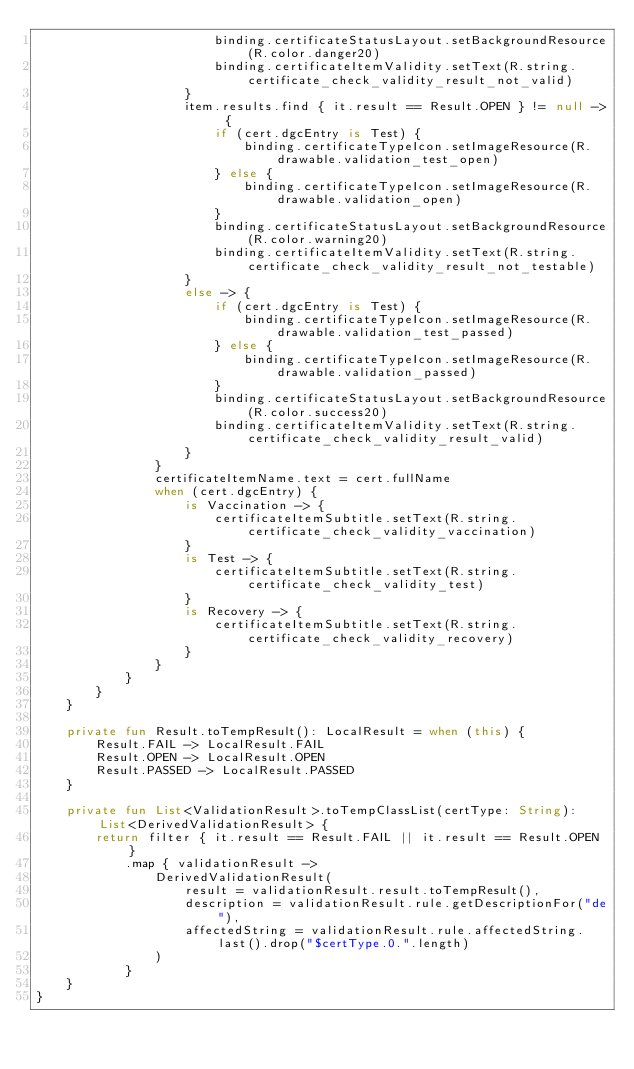<code> <loc_0><loc_0><loc_500><loc_500><_Kotlin_>                        binding.certificateStatusLayout.setBackgroundResource(R.color.danger20)
                        binding.certificateItemValidity.setText(R.string.certificate_check_validity_result_not_valid)
                    }
                    item.results.find { it.result == Result.OPEN } != null -> {
                        if (cert.dgcEntry is Test) {
                            binding.certificateTypeIcon.setImageResource(R.drawable.validation_test_open)
                        } else {
                            binding.certificateTypeIcon.setImageResource(R.drawable.validation_open)
                        }
                        binding.certificateStatusLayout.setBackgroundResource(R.color.warning20)
                        binding.certificateItemValidity.setText(R.string.certificate_check_validity_result_not_testable)
                    }
                    else -> {
                        if (cert.dgcEntry is Test) {
                            binding.certificateTypeIcon.setImageResource(R.drawable.validation_test_passed)
                        } else {
                            binding.certificateTypeIcon.setImageResource(R.drawable.validation_passed)
                        }
                        binding.certificateStatusLayout.setBackgroundResource(R.color.success20)
                        binding.certificateItemValidity.setText(R.string.certificate_check_validity_result_valid)
                    }
                }
                certificateItemName.text = cert.fullName
                when (cert.dgcEntry) {
                    is Vaccination -> {
                        certificateItemSubtitle.setText(R.string.certificate_check_validity_vaccination)
                    }
                    is Test -> {
                        certificateItemSubtitle.setText(R.string.certificate_check_validity_test)
                    }
                    is Recovery -> {
                        certificateItemSubtitle.setText(R.string.certificate_check_validity_recovery)
                    }
                }
            }
        }
    }

    private fun Result.toTempResult(): LocalResult = when (this) {
        Result.FAIL -> LocalResult.FAIL
        Result.OPEN -> LocalResult.OPEN
        Result.PASSED -> LocalResult.PASSED
    }

    private fun List<ValidationResult>.toTempClassList(certType: String): List<DerivedValidationResult> {
        return filter { it.result == Result.FAIL || it.result == Result.OPEN }
            .map { validationResult ->
                DerivedValidationResult(
                    result = validationResult.result.toTempResult(),
                    description = validationResult.rule.getDescriptionFor("de"),
                    affectedString = validationResult.rule.affectedString.last().drop("$certType.0.".length)
                )
            }
    }
}
</code> 